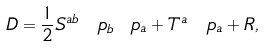Convert formula to latex. <formula><loc_0><loc_0><loc_500><loc_500>\ D = \frac { 1 } { 2 } S ^ { a b } \, \ p _ { b } \ p _ { a } + T ^ { a } \, \ p _ { a } + R ,</formula> 